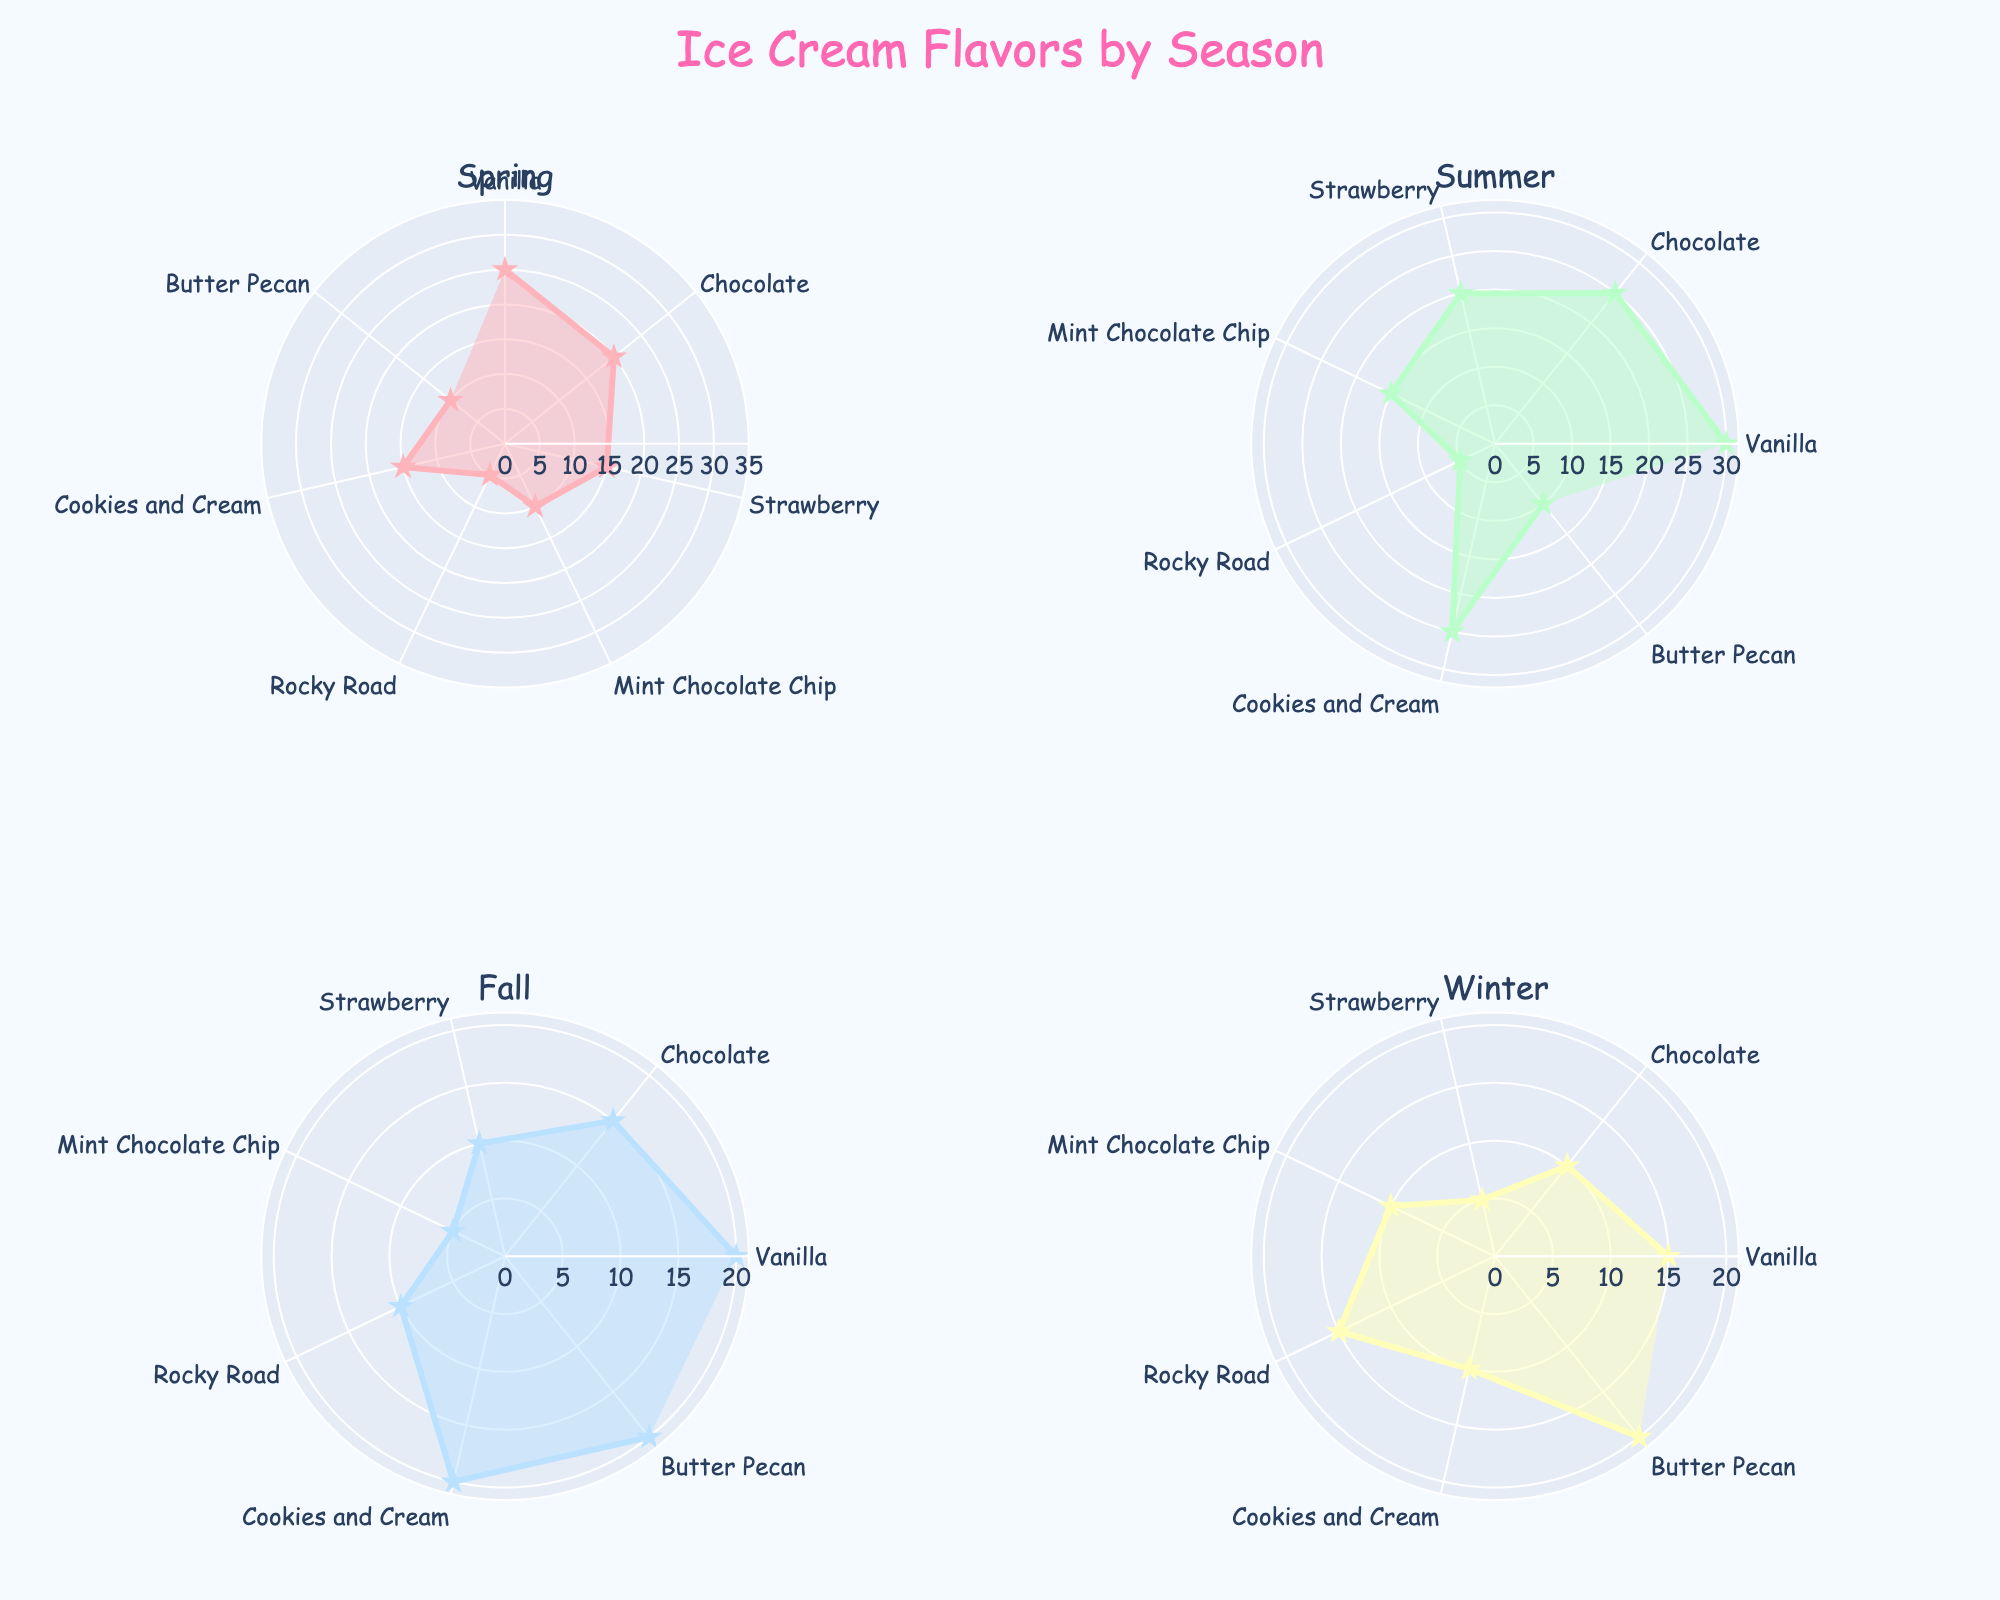What is the title of the figure? The title of the figure is located at the top of the chart, usually in a larger font size and more prominent than other texts. In this figure, it reads "Ice Cream Flavors by Season".
Answer: Ice Cream Flavors by Season Which season shows the highest preference for Vanilla ice cream? By examining each subplot for the seasons, we notice that the radial length for Vanilla ice cream is longest in Summer.
Answer: Summer How much more popular is Chocolate than Butter Pecan in Spring? Looking at the Spring subplot, Chocolate has a percentage of 20%, and Butter Pecan has 10%. The difference is calculated as 20% - 10% = 10%.
Answer: 10% During which season is Strawberry flavor the least preferred? By checking the subplots, we see that Winter has the smallest radial length (5%) for Strawberry flavor compared to the other seasons.
Answer: Winter What is the combined percentage of Mint Chocolate Chip in Spring and Fall? Mint Chocolate Chip has a percentage of 10% in Spring and 5% in Fall. Adding them gives 10% + 5% = 15%.
Answer: 15% Does any flavor in Fall have an equal preference to Rocky Road in Winter? Examining the subplots, we see that Rocky Road has a 15% preference in Winter. Cookies and Cream and Butter Pecan in Fall also have a 20% preference. None of the Fall flavors have a 15% preference.
Answer: No Which season has the highest percentage for Cookies and Cream? In the subplots, Cookies and Cream have the highest percentage in Summer with 25%.
Answer: Summer How does the preference for Rocky Road change from Fall to Winter? The preference for Rocky Road in Fall is 10% and increases to 15% in Winter. The change is calculated as 15% - 10% = 5%.
Answer: Increase by 5% Is there any flavor in Spring that has the same preference percentage as Mint Chocolate Chip in Summer? In the Summer subplot, Mint Chocolate Chip has a 15% preference. In Spring, Cookies and Cream also has a 15% preference.
Answer: Yes Which two flavors have the most significant preference difference during Summer? Observing the Summer subplot, Vanilla has the highest preference at 30% and Rocky Road has the lowest at 5%. The difference is calculated as 30% - 5% = 25%.
Answer: Vanilla and Rocky Road 